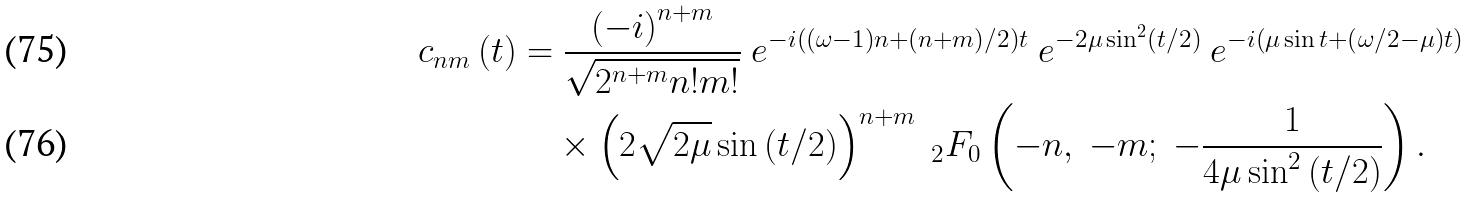Convert formula to latex. <formula><loc_0><loc_0><loc_500><loc_500>c _ { n m } \left ( t \right ) & = \frac { \left ( - i \right ) ^ { n + m } } { \sqrt { 2 ^ { n + m } n ! m ! } } \ e ^ { - i \left ( \left ( \omega - 1 \right ) n + \left ( n + m \right ) / 2 \right ) t } \ e ^ { - 2 \mu \sin ^ { 2 } \left ( t / 2 \right ) } \ e ^ { - i \left ( \mu \sin t + \left ( \omega / 2 - \mu \right ) t \right ) } \\ & \quad \times \left ( 2 \sqrt { 2 \mu } \sin \left ( t / 2 \right ) \right ) ^ { n + m } \ _ { 2 } F _ { 0 } \left ( - n , \ - m ; \ - \frac { 1 } { 4 \mu \sin ^ { 2 } \left ( t / 2 \right ) } \right ) .</formula> 